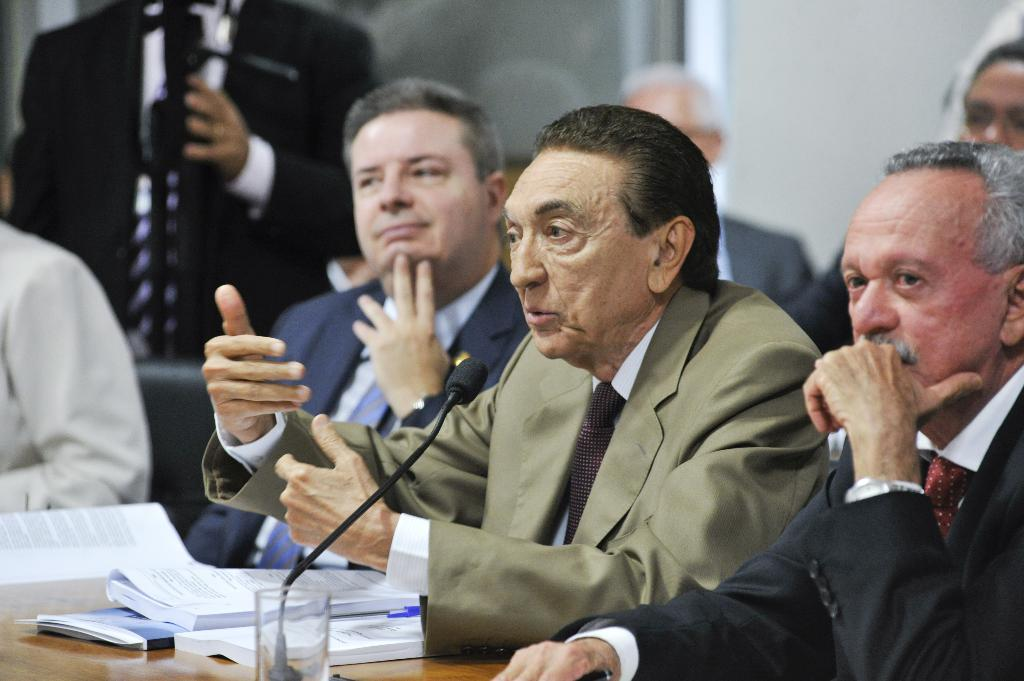What are the people in the image doing? The people in the image are sitting. What object is present that is typically used for amplifying sound? There is a microphone in the image. What type of container is visible in the image? There is a glass in the image. What items can be seen on the table in the image? There are books on the table in the image. What type of insect can be seen crawling on the microphone in the image? There are no insects present in the image, and therefore no insects can be seen crawling on the microphone. 